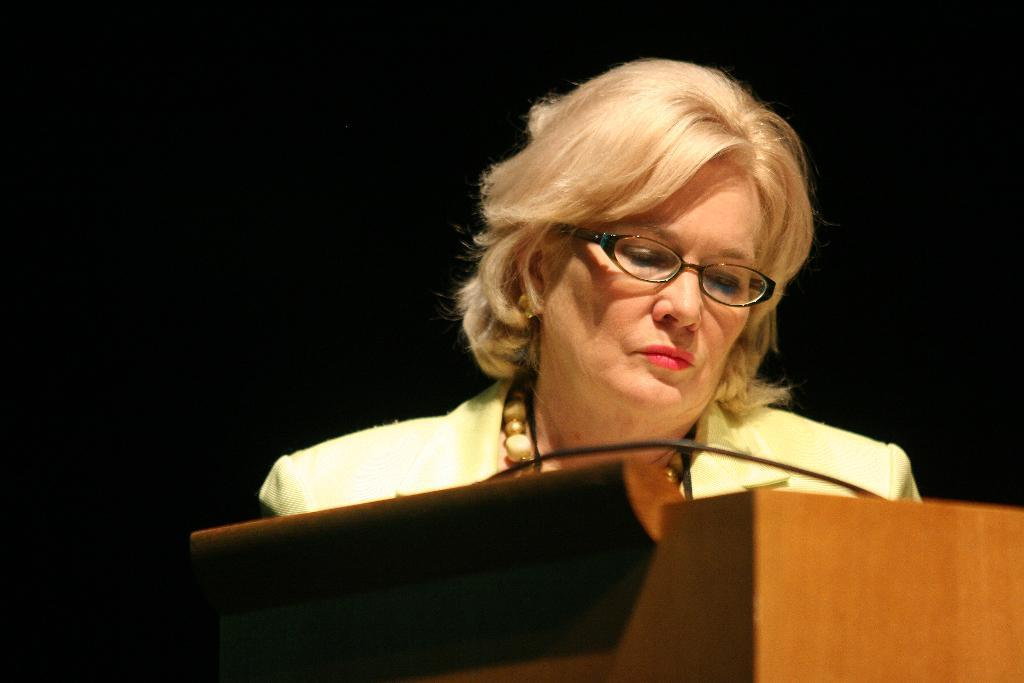Who is the main subject in the picture? There is a woman in the center of the picture. What is the woman wearing? The woman is wearing a suit. What object can be seen in the foreground of the image? There is a podium in the foreground. How would you describe the background of the image? The background of the image is dark. What type of creature can be seen folding its wings in the image? There is no creature present in the image, and therefore no such activity can be observed. 